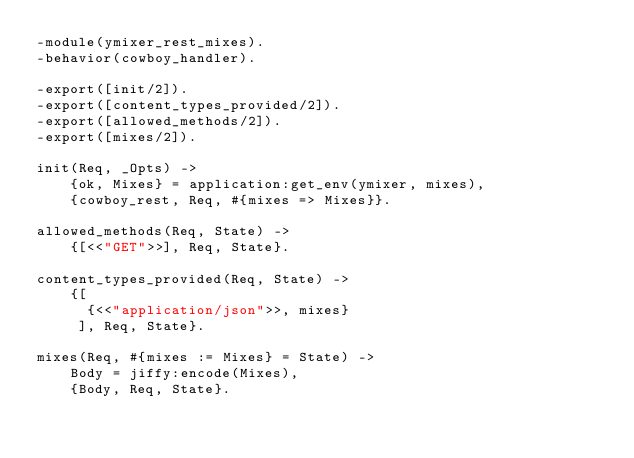Convert code to text. <code><loc_0><loc_0><loc_500><loc_500><_Erlang_>-module(ymixer_rest_mixes).
-behavior(cowboy_handler).

-export([init/2]).
-export([content_types_provided/2]).
-export([allowed_methods/2]).
-export([mixes/2]).

init(Req, _Opts) ->
    {ok, Mixes} = application:get_env(ymixer, mixes),
    {cowboy_rest, Req, #{mixes => Mixes}}.

allowed_methods(Req, State) ->
    {[<<"GET">>], Req, State}.

content_types_provided(Req, State) ->
    {[
      {<<"application/json">>, mixes}
     ], Req, State}.

mixes(Req, #{mixes := Mixes} = State) ->
    Body = jiffy:encode(Mixes),
    {Body, Req, State}.
</code> 